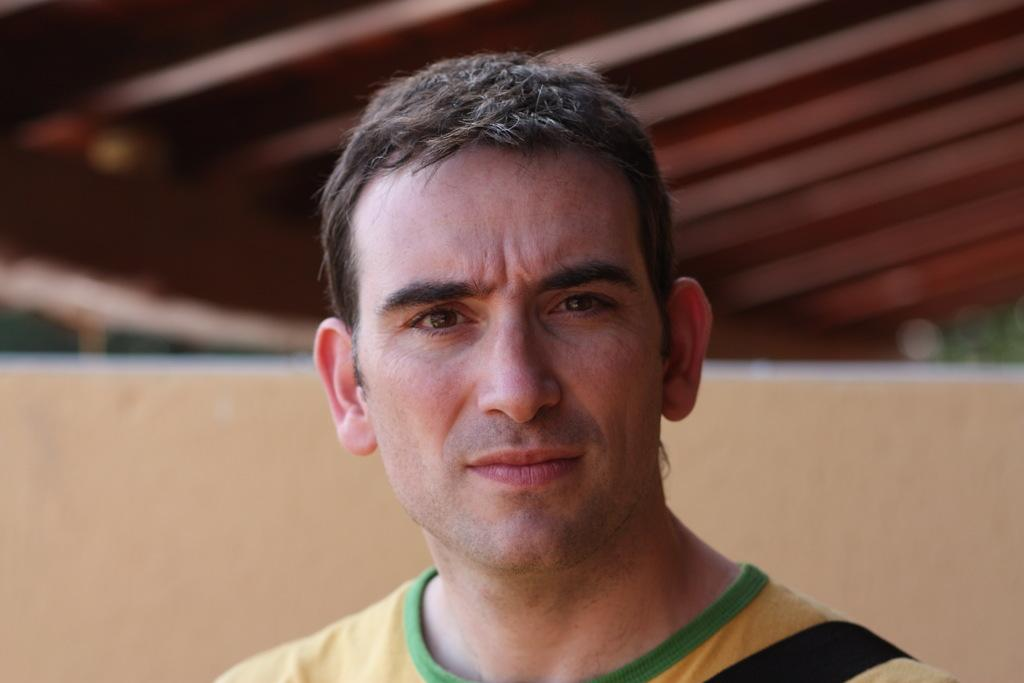Who is the main subject in the image? There is a man in the image. What is the man wearing? The man is wearing a T-shirt. What can be seen in the background of the image? There is a wall in the background of the image. What is visible at the top of the image? There appears to be a roof at the top of the image. What direction does the cannon face in the image? There is no cannon present in the image. How does the man start his day in the image? The image does not provide information about how the man starts his day. 